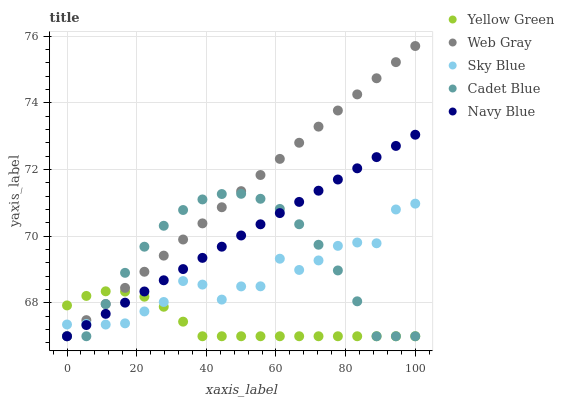Does Yellow Green have the minimum area under the curve?
Answer yes or no. Yes. Does Web Gray have the maximum area under the curve?
Answer yes or no. Yes. Does Sky Blue have the minimum area under the curve?
Answer yes or no. No. Does Sky Blue have the maximum area under the curve?
Answer yes or no. No. Is Web Gray the smoothest?
Answer yes or no. Yes. Is Sky Blue the roughest?
Answer yes or no. Yes. Is Sky Blue the smoothest?
Answer yes or no. No. Is Web Gray the roughest?
Answer yes or no. No. Does Cadet Blue have the lowest value?
Answer yes or no. Yes. Does Sky Blue have the lowest value?
Answer yes or no. No. Does Web Gray have the highest value?
Answer yes or no. Yes. Does Sky Blue have the highest value?
Answer yes or no. No. Does Yellow Green intersect Navy Blue?
Answer yes or no. Yes. Is Yellow Green less than Navy Blue?
Answer yes or no. No. Is Yellow Green greater than Navy Blue?
Answer yes or no. No. 